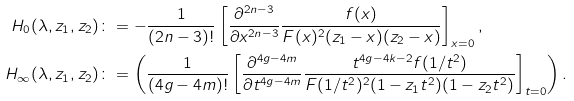<formula> <loc_0><loc_0><loc_500><loc_500>H _ { 0 } ( \lambda , z _ { 1 } , z _ { 2 } ) & \colon = - \frac { 1 } { ( 2 n - 3 ) ! } \left [ \frac { \partial ^ { 2 n - 3 } } { \partial x ^ { 2 n - 3 } } \frac { f ( x ) } { F ( x ) ^ { 2 } ( z _ { 1 } - x ) ( z _ { 2 } - x ) } \right ] _ { x = 0 } , \\ H _ { \infty } ( \lambda , z _ { 1 } , z _ { 2 } ) & \colon = \left ( \frac { 1 } { ( 4 g - 4 m ) ! } \left [ \frac { \partial ^ { 4 g - 4 m } } { \partial t ^ { 4 g - 4 m } } \frac { t ^ { 4 g - 4 k - 2 } f ( 1 / t ^ { 2 } ) } { F ( 1 / t ^ { 2 } ) ^ { 2 } ( 1 - z _ { 1 } t ^ { 2 } ) ( 1 - z _ { 2 } t ^ { 2 } ) } \right ] _ { t = 0 } \right ) .</formula> 